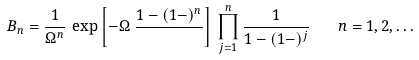Convert formula to latex. <formula><loc_0><loc_0><loc_500><loc_500>B _ { n } = \frac { 1 } { \Omega ^ { n } } \, \exp \left [ - \Omega \, \frac { 1 - ( 1 - ) ^ { n } } { } \right ] \, \prod _ { j = 1 } ^ { n } \frac { 1 } { 1 - ( 1 - ) ^ { j } } \quad n = 1 , 2 , \dots</formula> 